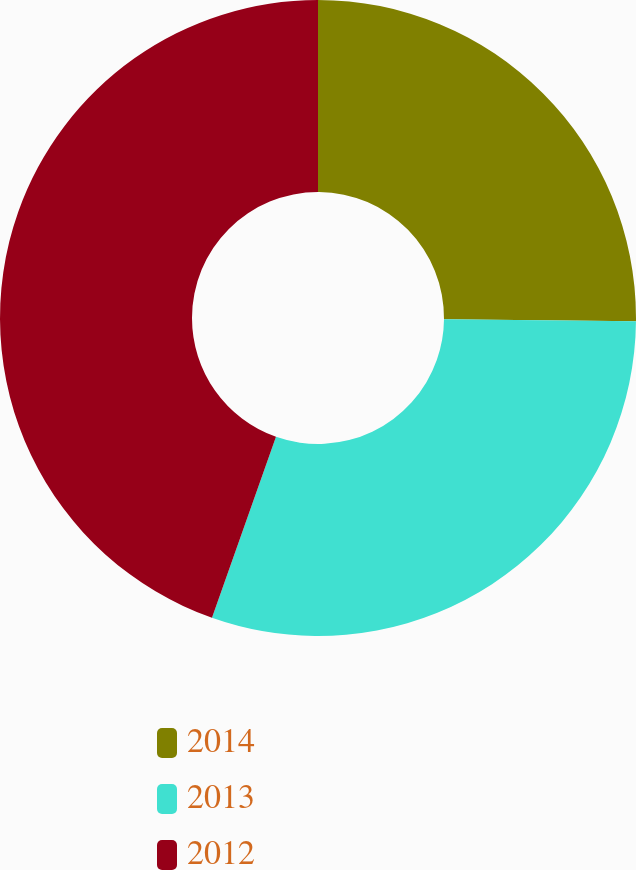<chart> <loc_0><loc_0><loc_500><loc_500><pie_chart><fcel>2014<fcel>2013<fcel>2012<nl><fcel>25.16%<fcel>30.25%<fcel>44.59%<nl></chart> 